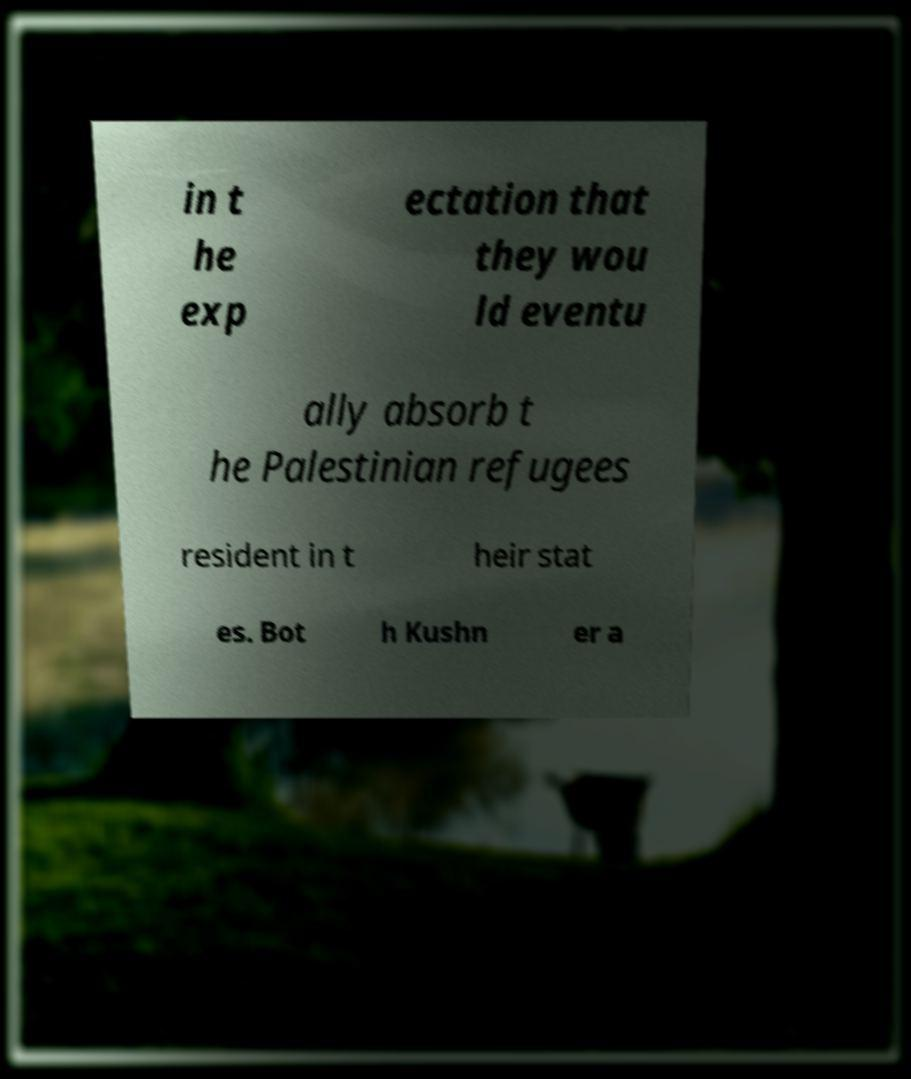For documentation purposes, I need the text within this image transcribed. Could you provide that? in t he exp ectation that they wou ld eventu ally absorb t he Palestinian refugees resident in t heir stat es. Bot h Kushn er a 